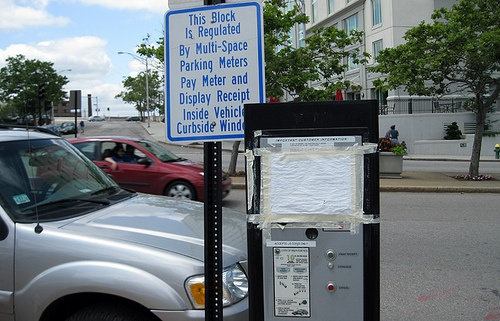Describe the objects in this image and their specific colors. I can see truck in lavender, black, gray, darkgray, and lightgray tones, car in lavender, black, darkgray, gray, and lightgray tones, parking meter in lavender, black, gray, darkgray, and lightgray tones, car in lavender, black, gray, maroon, and brown tones, and potted plant in lavender, gray, black, darkgreen, and maroon tones in this image. 